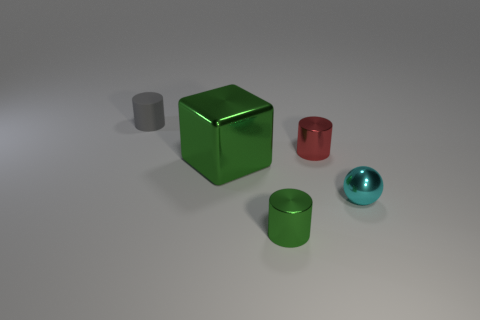Is there anything else that has the same size as the green metal block?
Keep it short and to the point. No. Is there anything else that has the same material as the tiny gray cylinder?
Your answer should be very brief. No. The metallic cylinder that is the same color as the large metal cube is what size?
Your answer should be compact. Small. Do the metallic thing behind the big metal block and the small green thing have the same shape?
Provide a short and direct response. Yes. Is the number of big green objects in front of the gray cylinder greater than the number of red metallic cylinders that are to the right of the ball?
Make the answer very short. Yes. How many green objects are right of the tiny cylinder that is behind the red metallic thing?
Give a very brief answer. 2. There is a object that is the same color as the block; what is it made of?
Provide a short and direct response. Metal. How many other things are there of the same color as the rubber cylinder?
Provide a short and direct response. 0. There is a small metal cylinder on the right side of the green cylinder that is to the left of the cyan metal ball; what color is it?
Offer a very short reply. Red. Is there a small metal cylinder that has the same color as the big metal block?
Offer a terse response. Yes. 